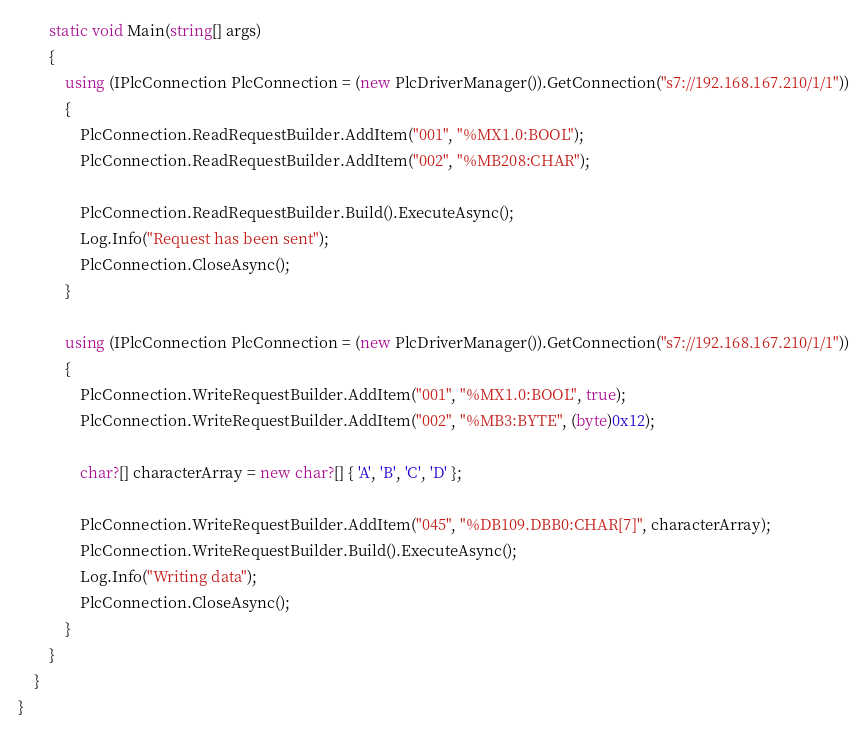<code> <loc_0><loc_0><loc_500><loc_500><_C#_>        static void Main(string[] args) 
        {
            using (IPlcConnection PlcConnection = (new PlcDriverManager()).GetConnection("s7://192.168.167.210/1/1"))
            {
                PlcConnection.ReadRequestBuilder.AddItem("001", "%MX1.0:BOOL");
                PlcConnection.ReadRequestBuilder.AddItem("002", "%MB208:CHAR");
                
                PlcConnection.ReadRequestBuilder.Build().ExecuteAsync();
                Log.Info("Request has been sent");
                PlcConnection.CloseAsync();
            }

            using (IPlcConnection PlcConnection = (new PlcDriverManager()).GetConnection("s7://192.168.167.210/1/1"))
            {
                PlcConnection.WriteRequestBuilder.AddItem("001", "%MX1.0:BOOL", true);
                PlcConnection.WriteRequestBuilder.AddItem("002", "%MB3:BYTE", (byte)0x12);

                char?[] characterArray = new char?[] { 'A', 'B', 'C', 'D' };

                PlcConnection.WriteRequestBuilder.AddItem("045", "%DB109.DBB0:CHAR[7]", characterArray);
                PlcConnection.WriteRequestBuilder.Build().ExecuteAsync();
                Log.Info("Writing data");
                PlcConnection.CloseAsync();
            }
        }
    }
}
</code> 